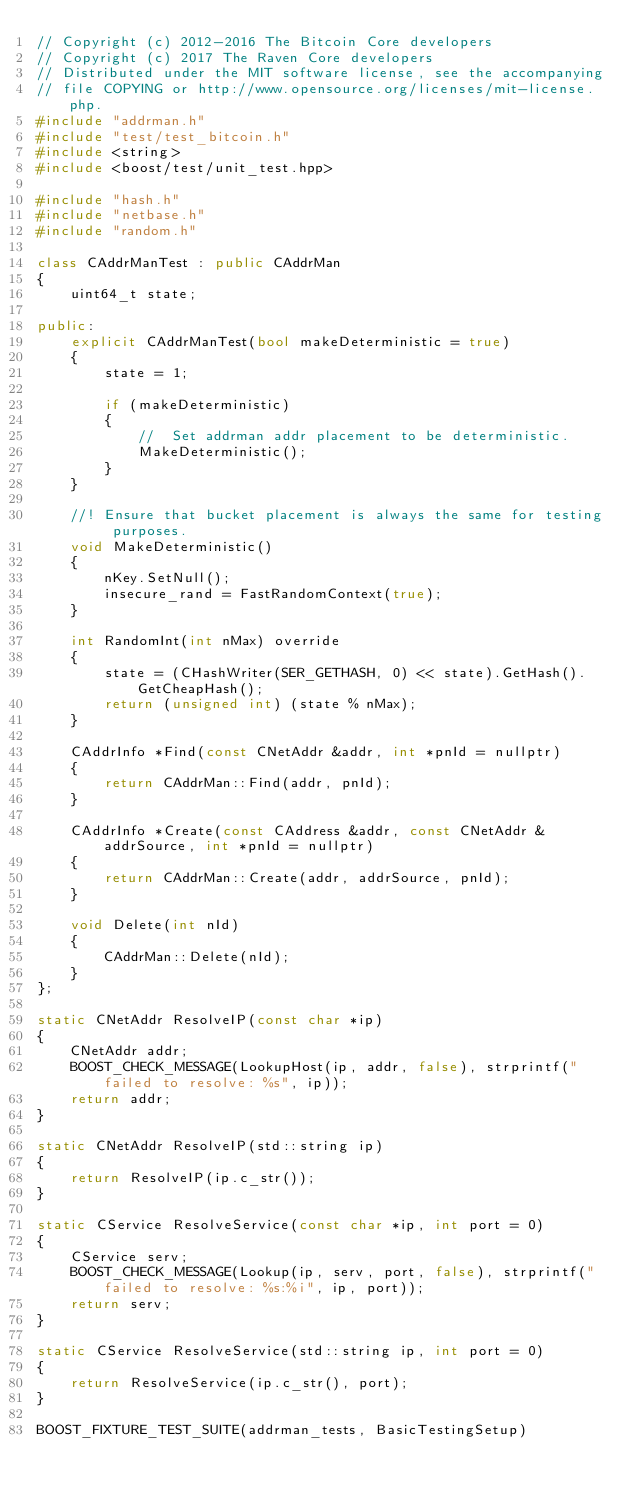Convert code to text. <code><loc_0><loc_0><loc_500><loc_500><_C++_>// Copyright (c) 2012-2016 The Bitcoin Core developers
// Copyright (c) 2017 The Raven Core developers
// Distributed under the MIT software license, see the accompanying
// file COPYING or http://www.opensource.org/licenses/mit-license.php.
#include "addrman.h"
#include "test/test_bitcoin.h"
#include <string>
#include <boost/test/unit_test.hpp>

#include "hash.h"
#include "netbase.h"
#include "random.h"

class CAddrManTest : public CAddrMan
{
    uint64_t state;

public:
    explicit CAddrManTest(bool makeDeterministic = true)
    {
        state = 1;

        if (makeDeterministic)
        {
            //  Set addrman addr placement to be deterministic.
            MakeDeterministic();
        }
    }

    //! Ensure that bucket placement is always the same for testing purposes.
    void MakeDeterministic()
    {
        nKey.SetNull();
        insecure_rand = FastRandomContext(true);
    }

    int RandomInt(int nMax) override
    {
        state = (CHashWriter(SER_GETHASH, 0) << state).GetHash().GetCheapHash();
        return (unsigned int) (state % nMax);
    }

    CAddrInfo *Find(const CNetAddr &addr, int *pnId = nullptr)
    {
        return CAddrMan::Find(addr, pnId);
    }

    CAddrInfo *Create(const CAddress &addr, const CNetAddr &addrSource, int *pnId = nullptr)
    {
        return CAddrMan::Create(addr, addrSource, pnId);
    }

    void Delete(int nId)
    {
        CAddrMan::Delete(nId);
    }
};

static CNetAddr ResolveIP(const char *ip)
{
    CNetAddr addr;
    BOOST_CHECK_MESSAGE(LookupHost(ip, addr, false), strprintf("failed to resolve: %s", ip));
    return addr;
}

static CNetAddr ResolveIP(std::string ip)
{
    return ResolveIP(ip.c_str());
}

static CService ResolveService(const char *ip, int port = 0)
{
    CService serv;
    BOOST_CHECK_MESSAGE(Lookup(ip, serv, port, false), strprintf("failed to resolve: %s:%i", ip, port));
    return serv;
}

static CService ResolveService(std::string ip, int port = 0)
{
    return ResolveService(ip.c_str(), port);
}

BOOST_FIXTURE_TEST_SUITE(addrman_tests, BasicTestingSetup)
</code> 